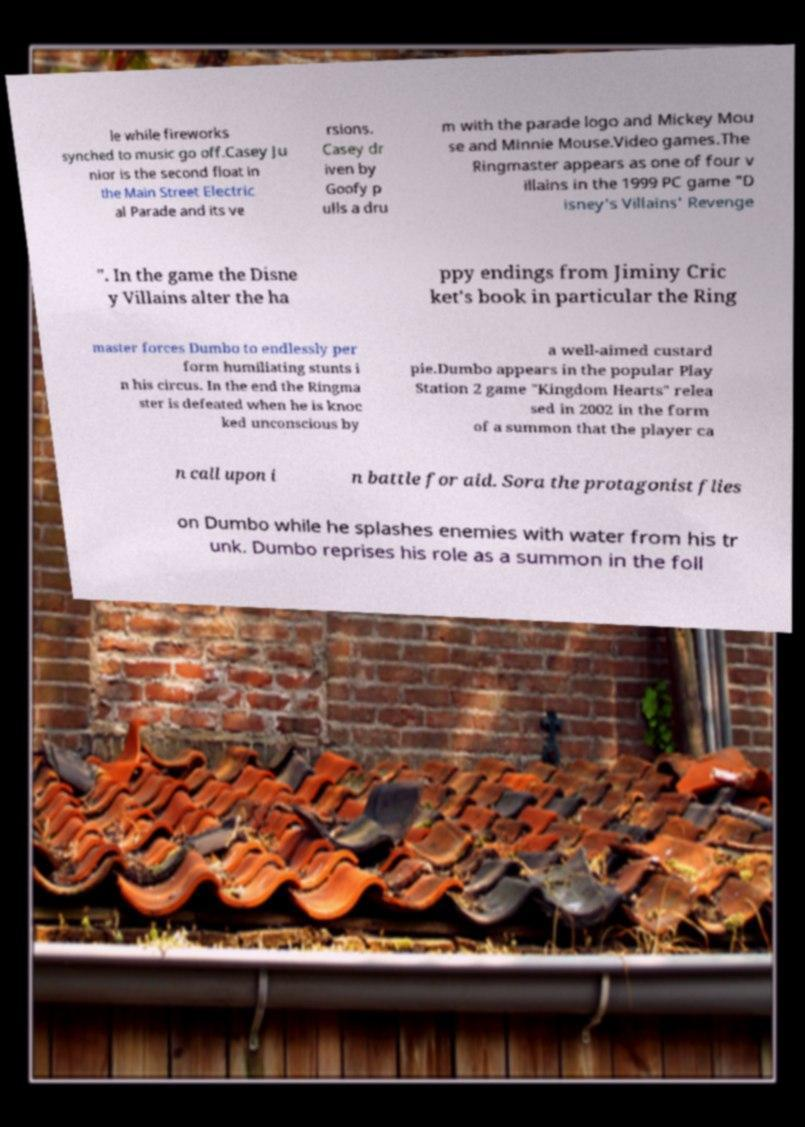Please identify and transcribe the text found in this image. le while fireworks synched to music go off.Casey Ju nior is the second float in the Main Street Electric al Parade and its ve rsions. Casey dr iven by Goofy p ulls a dru m with the parade logo and Mickey Mou se and Minnie Mouse.Video games.The Ringmaster appears as one of four v illains in the 1999 PC game "D isney's Villains' Revenge ". In the game the Disne y Villains alter the ha ppy endings from Jiminy Cric ket's book in particular the Ring master forces Dumbo to endlessly per form humiliating stunts i n his circus. In the end the Ringma ster is defeated when he is knoc ked unconscious by a well-aimed custard pie.Dumbo appears in the popular Play Station 2 game "Kingdom Hearts" relea sed in 2002 in the form of a summon that the player ca n call upon i n battle for aid. Sora the protagonist flies on Dumbo while he splashes enemies with water from his tr unk. Dumbo reprises his role as a summon in the foll 